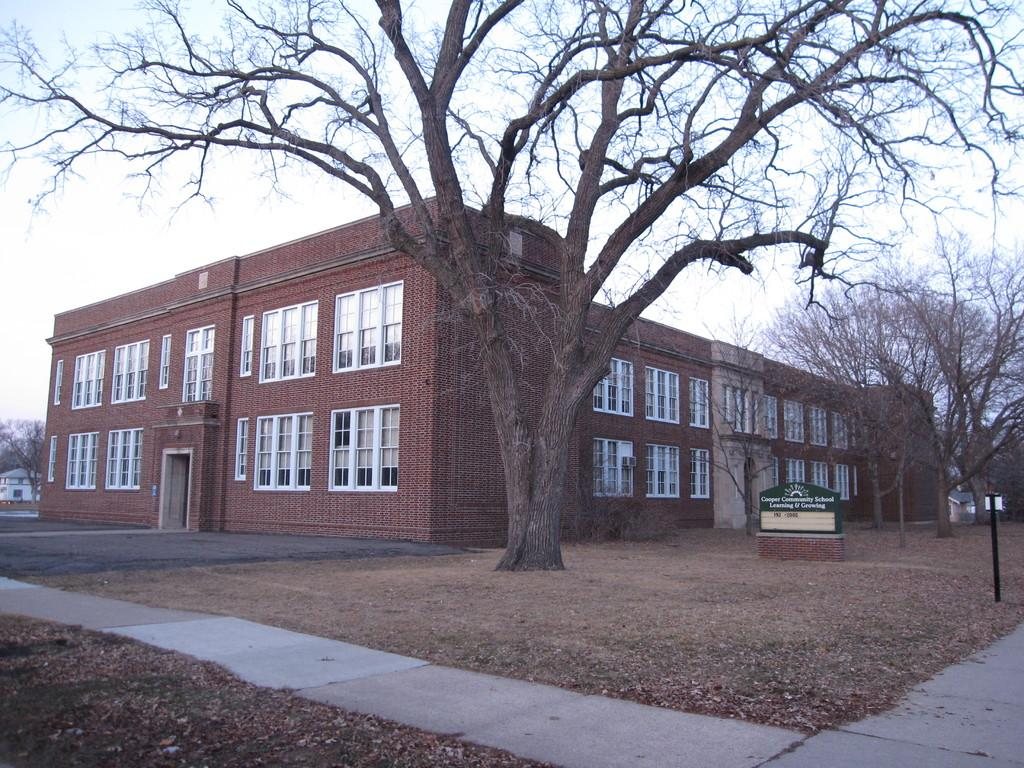What type of structures can be seen in the image? There are buildings in the image. What other natural elements are present in the image? There are trees in the image. Is there any text visible in the image? Yes, there is a board with text in the image. How would you describe the weather in the image? The sky is cloudy in the image. Can you see a person interacting with the crook in the image? There is no person or crook present in the image. 